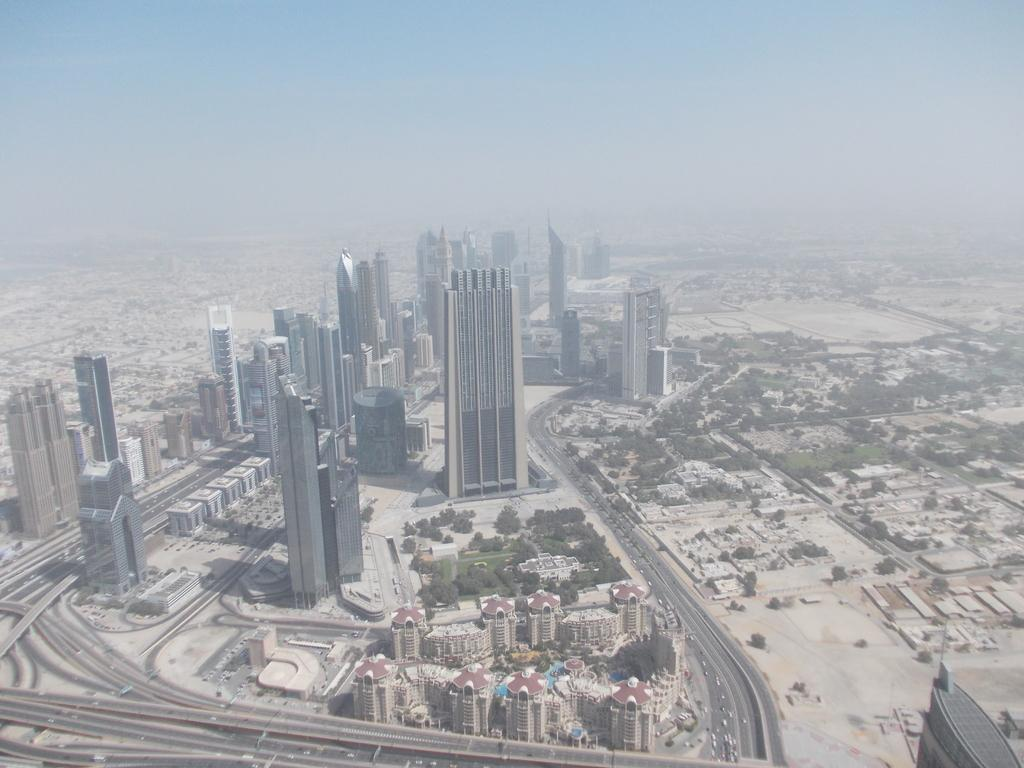What type of structures are present in the image? There is a group of buildings in the image. What other natural elements can be seen in the image? There are trees in the image. What type of man-made structures are at the bottom of the image? There are bridges at the bottom of the image. What else can be seen at the bottom of the image? There are vehicles at the bottom of the image. What is visible at the top of the image? The sky is visible at the top of the image. What color is the blood on the parcel in the image? There is no blood or parcel present in the image. What action is being performed by the vehicles in the image? The vehicles are stationary in the image, so no action is being performed. 